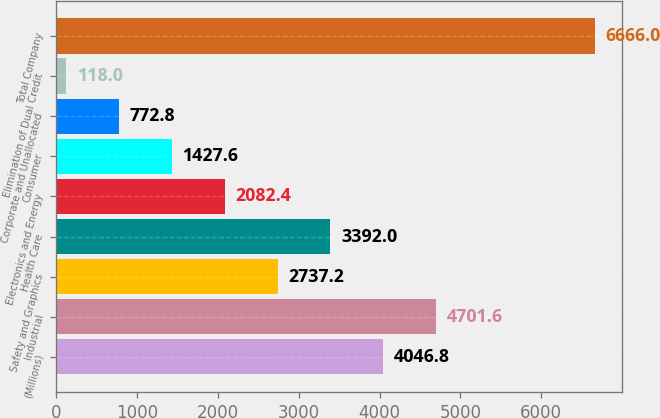Convert chart. <chart><loc_0><loc_0><loc_500><loc_500><bar_chart><fcel>(Millions)<fcel>Industrial<fcel>Safety and Graphics<fcel>Health Care<fcel>Electronics and Energy<fcel>Consumer<fcel>Corporate and Unallocated<fcel>Elimination of Dual Credit<fcel>Total Company<nl><fcel>4046.8<fcel>4701.6<fcel>2737.2<fcel>3392<fcel>2082.4<fcel>1427.6<fcel>772.8<fcel>118<fcel>6666<nl></chart> 